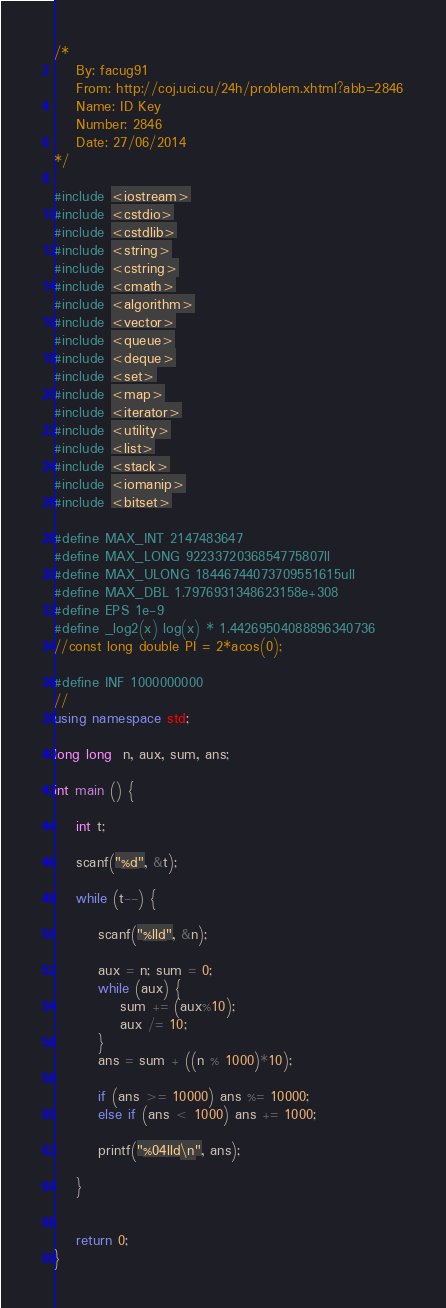Convert code to text. <code><loc_0><loc_0><loc_500><loc_500><_C++_>/*
	By: facug91
	From: http://coj.uci.cu/24h/problem.xhtml?abb=2846
	Name: ID Key
	Number: 2846
	Date: 27/06/2014
*/

#include <iostream>
#include <cstdio>
#include <cstdlib>
#include <string>
#include <cstring>
#include <cmath>
#include <algorithm>
#include <vector>
#include <queue>
#include <deque>
#include <set>
#include <map>
#include <iterator>
#include <utility>
#include <list>
#include <stack>
#include <iomanip>
#include <bitset>

#define MAX_INT 2147483647
#define MAX_LONG 9223372036854775807ll
#define MAX_ULONG 18446744073709551615ull
#define MAX_DBL 1.7976931348623158e+308
#define EPS 1e-9
#define _log2(x) log(x) * 1.44269504088896340736
//const long double PI = 2*acos(0);

#define INF 1000000000
//
using namespace std;

long long  n, aux, sum, ans;

int main () {
	
	int t;
	
	scanf("%d", &t);
	
	while (t--) {
		
		scanf("%lld", &n);
		
		aux = n; sum = 0;
		while (aux) {
			sum += (aux%10);
			aux /= 10;
		}
		ans = sum + ((n % 1000)*10);
		
		if (ans >= 10000) ans %= 10000;
		else if (ans < 1000) ans += 1000;
		
		printf("%04lld\n", ans);
		
	}
	
	
	return 0;
}
</code> 